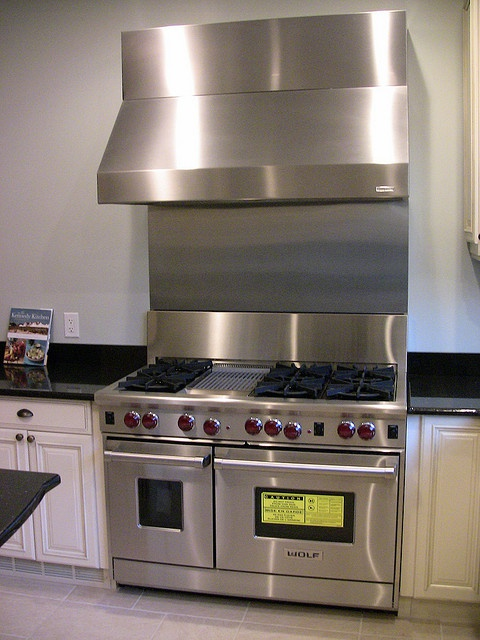Describe the objects in this image and their specific colors. I can see oven in gray, black, and tan tones, oven in gray, black, navy, and darkgray tones, and book in gray, black, darkgray, and maroon tones in this image. 